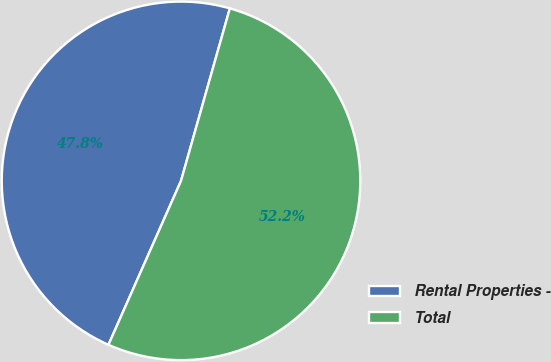Convert chart to OTSL. <chart><loc_0><loc_0><loc_500><loc_500><pie_chart><fcel>Rental Properties -<fcel>Total<nl><fcel>47.76%<fcel>52.24%<nl></chart> 